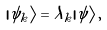Convert formula to latex. <formula><loc_0><loc_0><loc_500><loc_500>| \psi _ { k } \rangle = \lambda _ { k } | \tilde { \psi } \rangle \, ,</formula> 